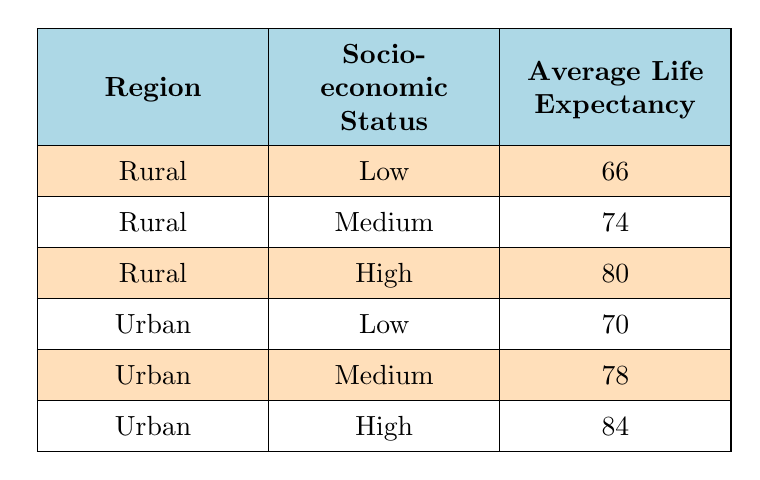What is the average life expectancy in rural communities with high socio-economic status? The table indicates that in rural communities with a high socio-economic status, the average life expectancy is listed as 80.
Answer: 80 What are the main health issues affecting urban communities with low socio-economic status? The table states that urban communities with low socio-economic status face main health issues such as air pollution, violence-related injuries, and obesity.
Answer: Air pollution, violence-related injuries, obesity How much higher is the average life expectancy in urban areas compared to rural areas for those with medium socio-economic status? For rural communities with medium socio-economic status, the average life expectancy is 74. In urban areas, this figure is 78. The difference is calculated as 78 - 74 = 4.
Answer: 4 Is the average life expectancy in rural communities with low socio-economic status greater than in urban communities with low socio-economic status? According to the table, the average life expectancy in rural communities with low socio-economic status is 66, whereas in urban communities it is 70. Since 66 is less than 70, the statement is false.
Answer: No What is the average life expectancy of individuals in rural communities with high socio-economic status compared to those in urban communities with high socio-economic status? The table shows that the average life expectancy for rural communities with high socio-economic status is 80, while for urban communities it is 84. Therefore, urban community members have a higher life expectancy by 4 years (84 - 80).
Answer: 4 years What is the average life expectancy of rural communities with low and medium socio-economic statuses combined? The average life expectancy for low socio-economic status in rural areas is 66, and for medium socio-economic status it is 74. To find the combined average, we calculate (66 + 74) / 2 = 70.
Answer: 70 